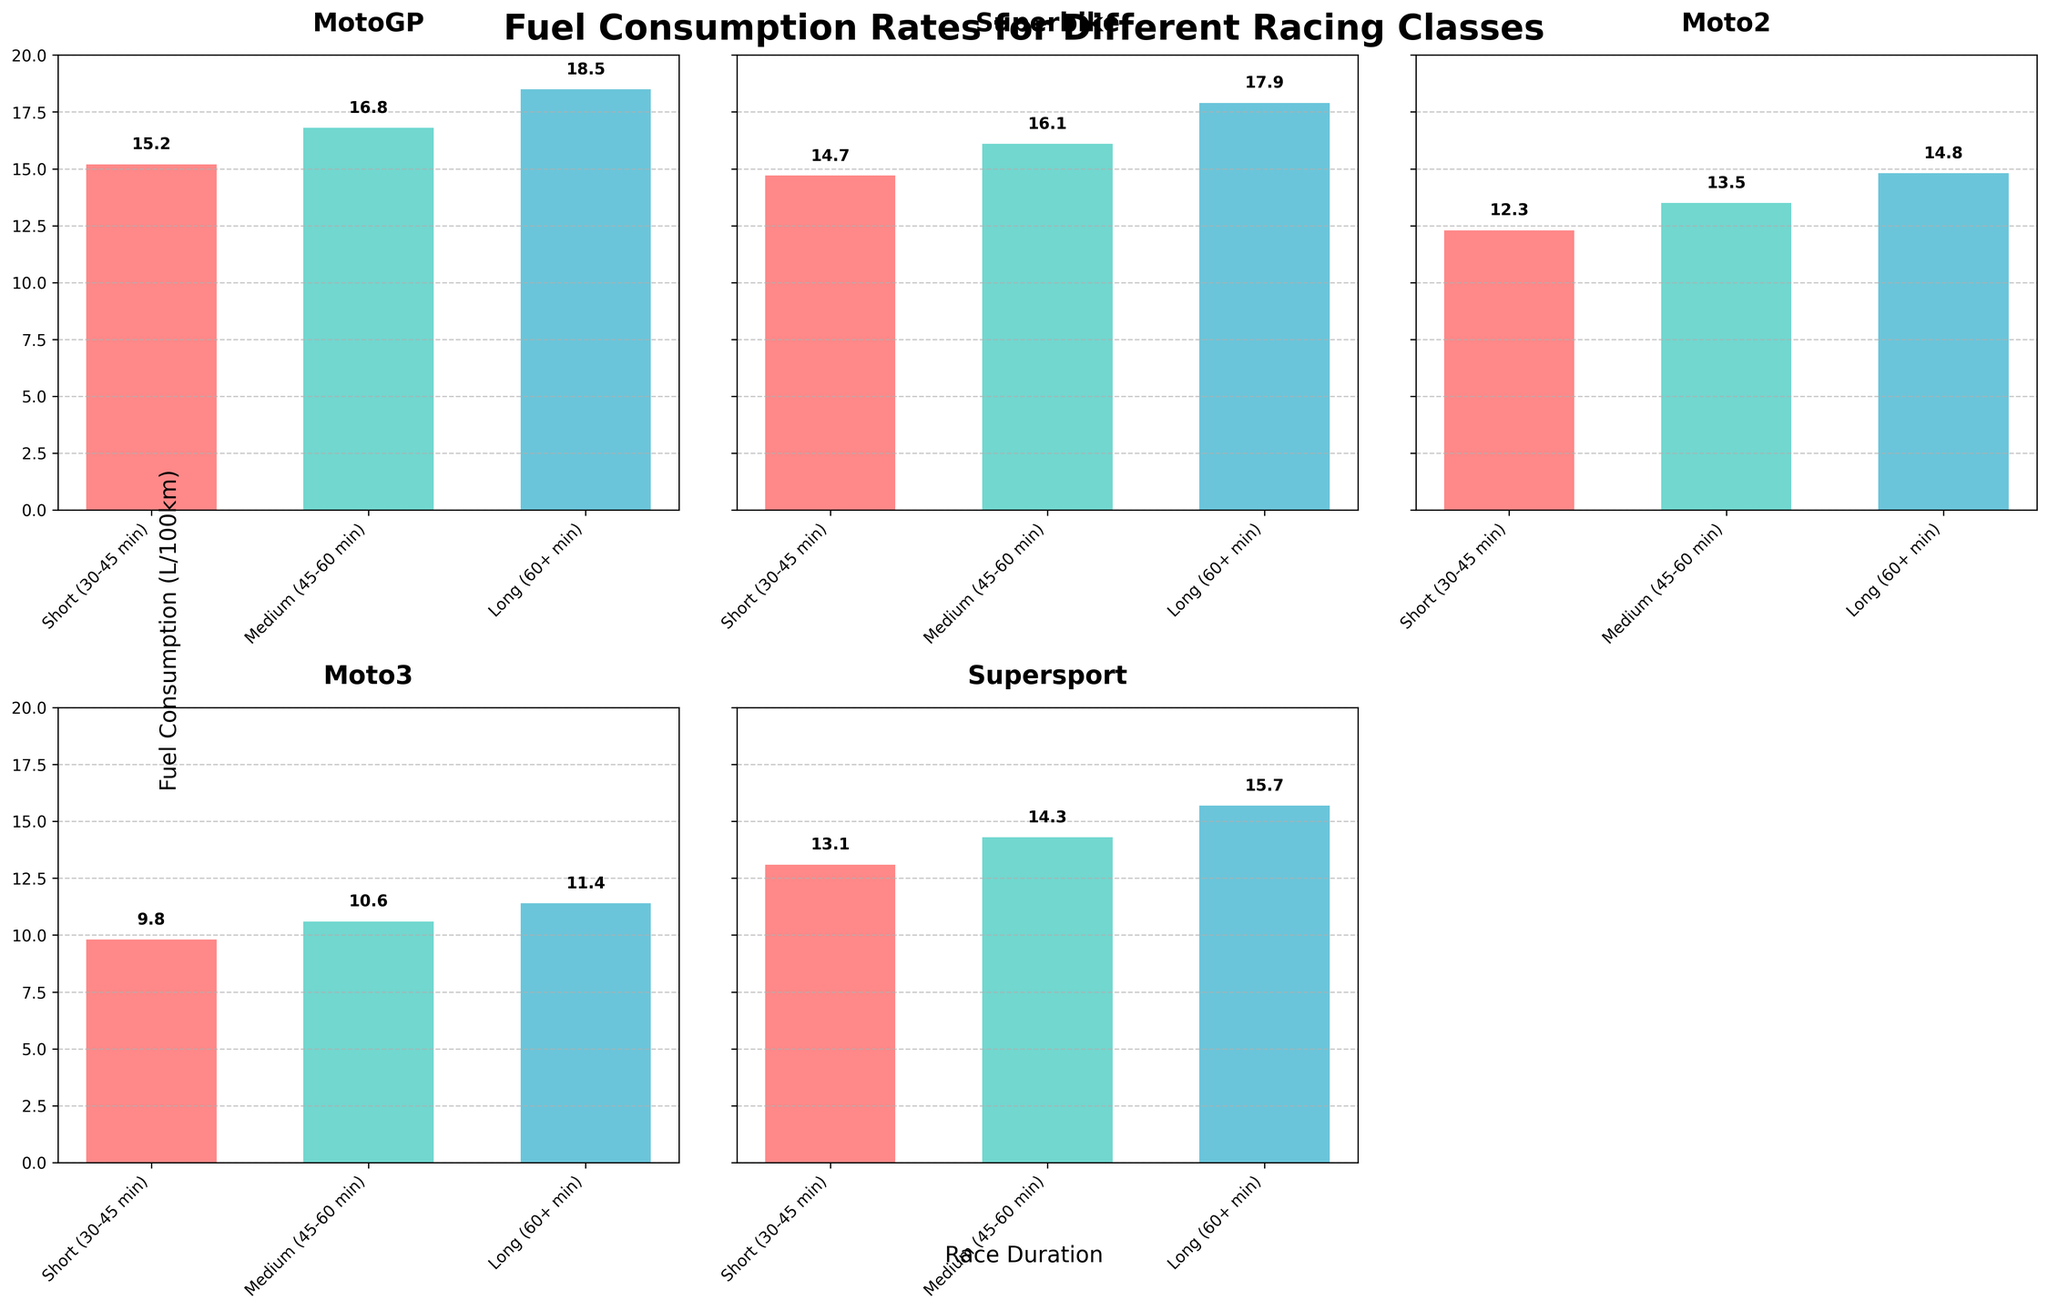What's the title of the plot? The plot's title is located at the top center of the figure. It reads, "Fuel Consumption Rates for Different Racing Classes."
Answer: Fuel Consumption Rates for Different Racing Classes What is the fuel consumption for Moto2 during medium race durations? Locate the bar labeled "Moto2" and find the height of the bar corresponding to the "Medium (45-60 min)" duration. The text near this bar gives the exact value of fuel consumption.
Answer: 13.5 L/100km Which racing class has the highest fuel consumption for long race durations? Compare the heights of the bars across different racing classes for the "Long (60+ min)" duration. The tallest bar represents the highest fuel consumption.
Answer: MotoGP What is the difference in fuel consumption between MotoGP and Moto3 for short race durations? Identify and note the fuel consumption values for "MotoGP" and "Moto3" in the "Short (30-45 min)" duration. Subtract the value of Moto3 from MotoGP to find the difference.
Answer: 5.4 L/100km Which racing class shows the smallest increase in fuel consumption from medium to long race durations? For each racing class, calculate the increase in fuel consumption by subtracting the "Medium (45-60 min)" value from the "Long (60+ min)" value. Compare these increases to find the smallest one.
Answer: Moto3 On average, how much fuel do all racing classes consume during short race durations? Sum the fuel consumption values of all racing classes for the "Short (30-45 min)" duration and divide by the number of classes (5 in this case). The operation is (15.2 + 14.7 + 12.3 + 9.8 + 13.1)/5 = 65.1/5 = 13.02.
Answer: 13.02 L/100km When considering all race durations, which class has the highest average fuel consumption? Calculate the average fuel consumption across all durations for each racing class by summing their fuel consumption values and dividing by the number of durations. Compare these averages to determine the highest.
Answer: MotoGP What’s the median fuel consumption for Supersport racing class? List the fuel consumption values of the Supersport racing class across all durations and find the middle value. Since the values are 13.1, 14.3, and 15.7, the median is the middle value, 14.3.
Answer: 14.3 L/100km Which class exhibits more consistent fuel consumption across all race durations, Moto2 or Superbike? Calculate the variance or range of fuel consumption values for Moto2 and Superbike classes. For Moto2 (12.3, 13.5, 14.8) and for Superbike (14.7, 16.1, 17.9). Compare the spread of values to identify more consistent consumption.
Answer: Moto2 